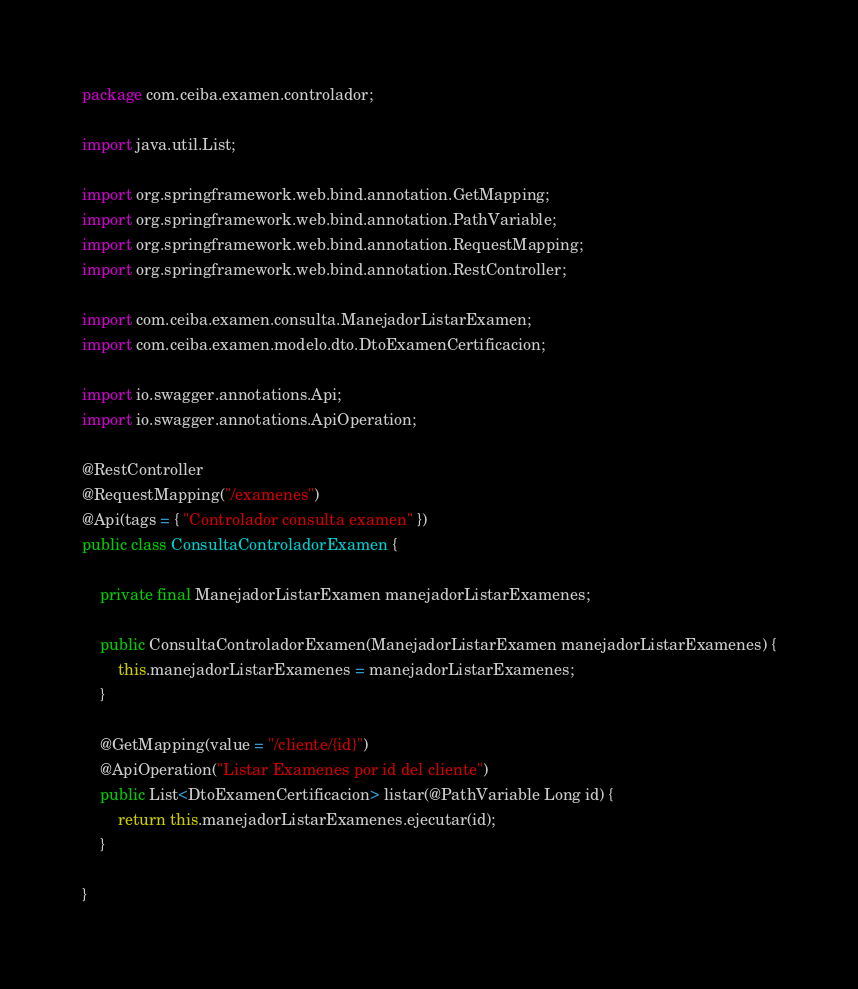Convert code to text. <code><loc_0><loc_0><loc_500><loc_500><_Java_>package com.ceiba.examen.controlador;

import java.util.List;

import org.springframework.web.bind.annotation.GetMapping;
import org.springframework.web.bind.annotation.PathVariable;
import org.springframework.web.bind.annotation.RequestMapping;
import org.springframework.web.bind.annotation.RestController;

import com.ceiba.examen.consulta.ManejadorListarExamen;
import com.ceiba.examen.modelo.dto.DtoExamenCertificacion;

import io.swagger.annotations.Api;
import io.swagger.annotations.ApiOperation;

@RestController
@RequestMapping("/examenes")
@Api(tags = { "Controlador consulta examen" })
public class ConsultaControladorExamen {

	private final ManejadorListarExamen manejadorListarExamenes;

	public ConsultaControladorExamen(ManejadorListarExamen manejadorListarExamenes) {
		this.manejadorListarExamenes = manejadorListarExamenes;
	}

	@GetMapping(value = "/cliente/{id}")
	@ApiOperation("Listar Examenes por id del cliente")
	public List<DtoExamenCertificacion> listar(@PathVariable Long id) {
		return this.manejadorListarExamenes.ejecutar(id);
	}

}
</code> 